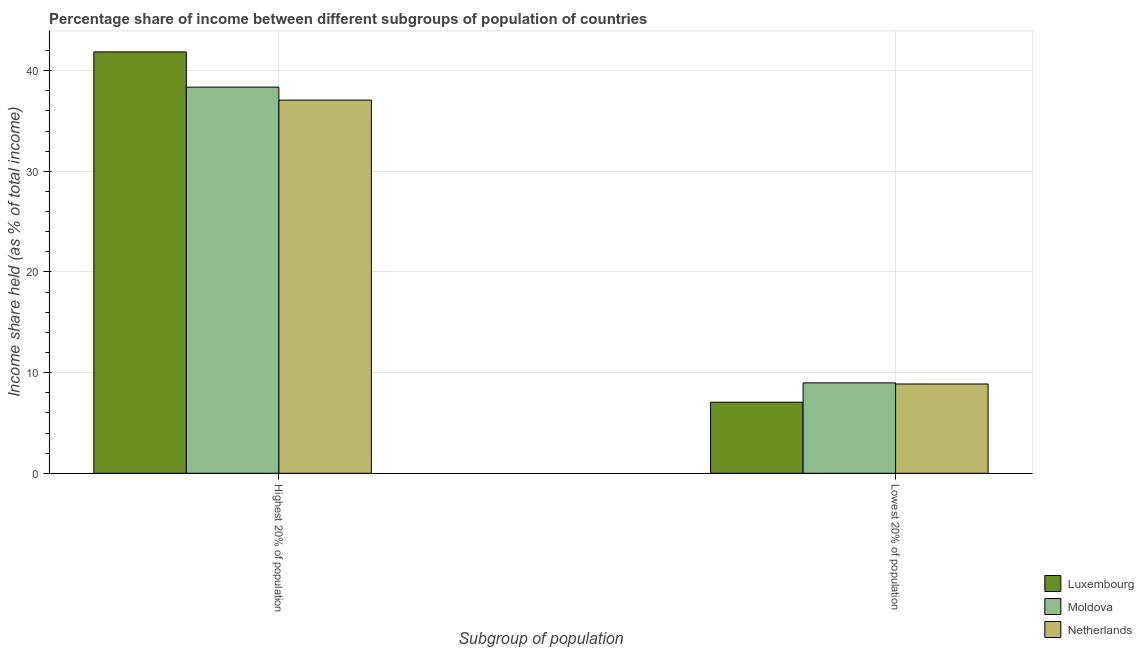How many groups of bars are there?
Keep it short and to the point. 2. How many bars are there on the 1st tick from the right?
Offer a very short reply. 3. What is the label of the 1st group of bars from the left?
Offer a very short reply. Highest 20% of population. What is the income share held by lowest 20% of the population in Luxembourg?
Your response must be concise. 7.06. Across all countries, what is the maximum income share held by highest 20% of the population?
Keep it short and to the point. 41.86. Across all countries, what is the minimum income share held by highest 20% of the population?
Ensure brevity in your answer.  37.07. In which country was the income share held by highest 20% of the population maximum?
Keep it short and to the point. Luxembourg. What is the total income share held by lowest 20% of the population in the graph?
Make the answer very short. 24.91. What is the difference between the income share held by highest 20% of the population in Luxembourg and that in Netherlands?
Offer a terse response. 4.79. What is the difference between the income share held by highest 20% of the population in Luxembourg and the income share held by lowest 20% of the population in Moldova?
Give a very brief answer. 32.88. What is the average income share held by highest 20% of the population per country?
Offer a terse response. 39.1. What is the difference between the income share held by highest 20% of the population and income share held by lowest 20% of the population in Netherlands?
Give a very brief answer. 28.2. What is the ratio of the income share held by highest 20% of the population in Netherlands to that in Luxembourg?
Your answer should be very brief. 0.89. What does the 2nd bar from the left in Lowest 20% of population represents?
Ensure brevity in your answer.  Moldova. What does the 1st bar from the right in Lowest 20% of population represents?
Provide a succinct answer. Netherlands. Are the values on the major ticks of Y-axis written in scientific E-notation?
Your answer should be compact. No. Does the graph contain grids?
Offer a terse response. Yes. Where does the legend appear in the graph?
Make the answer very short. Bottom right. How many legend labels are there?
Provide a succinct answer. 3. What is the title of the graph?
Your answer should be compact. Percentage share of income between different subgroups of population of countries. Does "Central Europe" appear as one of the legend labels in the graph?
Keep it short and to the point. No. What is the label or title of the X-axis?
Give a very brief answer. Subgroup of population. What is the label or title of the Y-axis?
Give a very brief answer. Income share held (as % of total income). What is the Income share held (as % of total income) in Luxembourg in Highest 20% of population?
Offer a terse response. 41.86. What is the Income share held (as % of total income) in Moldova in Highest 20% of population?
Your response must be concise. 38.36. What is the Income share held (as % of total income) in Netherlands in Highest 20% of population?
Offer a very short reply. 37.07. What is the Income share held (as % of total income) of Luxembourg in Lowest 20% of population?
Provide a short and direct response. 7.06. What is the Income share held (as % of total income) in Moldova in Lowest 20% of population?
Your answer should be compact. 8.98. What is the Income share held (as % of total income) of Netherlands in Lowest 20% of population?
Your answer should be compact. 8.87. Across all Subgroup of population, what is the maximum Income share held (as % of total income) in Luxembourg?
Your answer should be very brief. 41.86. Across all Subgroup of population, what is the maximum Income share held (as % of total income) in Moldova?
Give a very brief answer. 38.36. Across all Subgroup of population, what is the maximum Income share held (as % of total income) of Netherlands?
Keep it short and to the point. 37.07. Across all Subgroup of population, what is the minimum Income share held (as % of total income) in Luxembourg?
Your answer should be compact. 7.06. Across all Subgroup of population, what is the minimum Income share held (as % of total income) of Moldova?
Your response must be concise. 8.98. Across all Subgroup of population, what is the minimum Income share held (as % of total income) of Netherlands?
Keep it short and to the point. 8.87. What is the total Income share held (as % of total income) of Luxembourg in the graph?
Offer a terse response. 48.92. What is the total Income share held (as % of total income) in Moldova in the graph?
Your response must be concise. 47.34. What is the total Income share held (as % of total income) in Netherlands in the graph?
Your answer should be compact. 45.94. What is the difference between the Income share held (as % of total income) in Luxembourg in Highest 20% of population and that in Lowest 20% of population?
Your answer should be compact. 34.8. What is the difference between the Income share held (as % of total income) of Moldova in Highest 20% of population and that in Lowest 20% of population?
Keep it short and to the point. 29.38. What is the difference between the Income share held (as % of total income) of Netherlands in Highest 20% of population and that in Lowest 20% of population?
Ensure brevity in your answer.  28.2. What is the difference between the Income share held (as % of total income) in Luxembourg in Highest 20% of population and the Income share held (as % of total income) in Moldova in Lowest 20% of population?
Keep it short and to the point. 32.88. What is the difference between the Income share held (as % of total income) of Luxembourg in Highest 20% of population and the Income share held (as % of total income) of Netherlands in Lowest 20% of population?
Offer a terse response. 32.99. What is the difference between the Income share held (as % of total income) of Moldova in Highest 20% of population and the Income share held (as % of total income) of Netherlands in Lowest 20% of population?
Your response must be concise. 29.49. What is the average Income share held (as % of total income) of Luxembourg per Subgroup of population?
Offer a very short reply. 24.46. What is the average Income share held (as % of total income) of Moldova per Subgroup of population?
Provide a short and direct response. 23.67. What is the average Income share held (as % of total income) in Netherlands per Subgroup of population?
Ensure brevity in your answer.  22.97. What is the difference between the Income share held (as % of total income) in Luxembourg and Income share held (as % of total income) in Netherlands in Highest 20% of population?
Your answer should be very brief. 4.79. What is the difference between the Income share held (as % of total income) in Moldova and Income share held (as % of total income) in Netherlands in Highest 20% of population?
Your answer should be compact. 1.29. What is the difference between the Income share held (as % of total income) of Luxembourg and Income share held (as % of total income) of Moldova in Lowest 20% of population?
Your response must be concise. -1.92. What is the difference between the Income share held (as % of total income) in Luxembourg and Income share held (as % of total income) in Netherlands in Lowest 20% of population?
Offer a terse response. -1.81. What is the difference between the Income share held (as % of total income) of Moldova and Income share held (as % of total income) of Netherlands in Lowest 20% of population?
Give a very brief answer. 0.11. What is the ratio of the Income share held (as % of total income) in Luxembourg in Highest 20% of population to that in Lowest 20% of population?
Your answer should be very brief. 5.93. What is the ratio of the Income share held (as % of total income) in Moldova in Highest 20% of population to that in Lowest 20% of population?
Your answer should be compact. 4.27. What is the ratio of the Income share held (as % of total income) in Netherlands in Highest 20% of population to that in Lowest 20% of population?
Your answer should be very brief. 4.18. What is the difference between the highest and the second highest Income share held (as % of total income) in Luxembourg?
Your answer should be compact. 34.8. What is the difference between the highest and the second highest Income share held (as % of total income) of Moldova?
Offer a very short reply. 29.38. What is the difference between the highest and the second highest Income share held (as % of total income) of Netherlands?
Your response must be concise. 28.2. What is the difference between the highest and the lowest Income share held (as % of total income) in Luxembourg?
Offer a very short reply. 34.8. What is the difference between the highest and the lowest Income share held (as % of total income) in Moldova?
Offer a terse response. 29.38. What is the difference between the highest and the lowest Income share held (as % of total income) of Netherlands?
Ensure brevity in your answer.  28.2. 